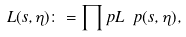<formula> <loc_0><loc_0><loc_500><loc_500>L ( s , \eta ) \colon = \prod _ { \ } p L _ { \ } p ( s , \eta ) ,</formula> 